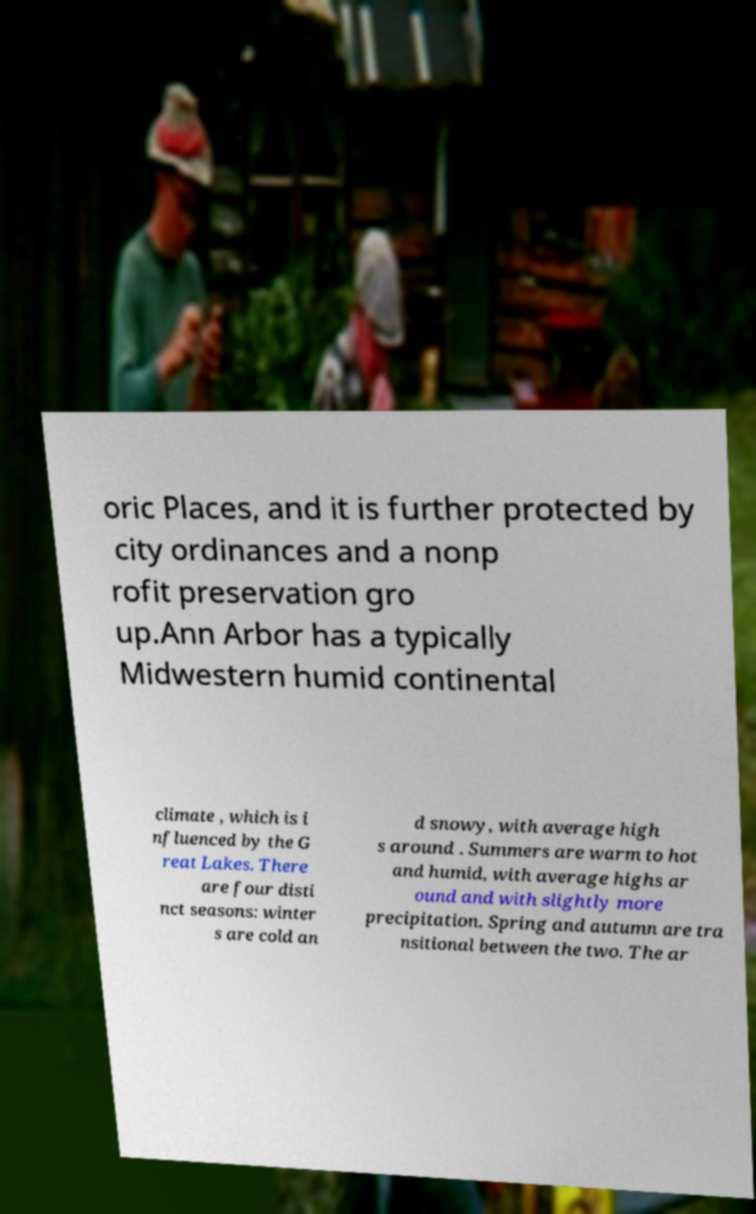I need the written content from this picture converted into text. Can you do that? oric Places, and it is further protected by city ordinances and a nonp rofit preservation gro up.Ann Arbor has a typically Midwestern humid continental climate , which is i nfluenced by the G reat Lakes. There are four disti nct seasons: winter s are cold an d snowy, with average high s around . Summers are warm to hot and humid, with average highs ar ound and with slightly more precipitation. Spring and autumn are tra nsitional between the two. The ar 